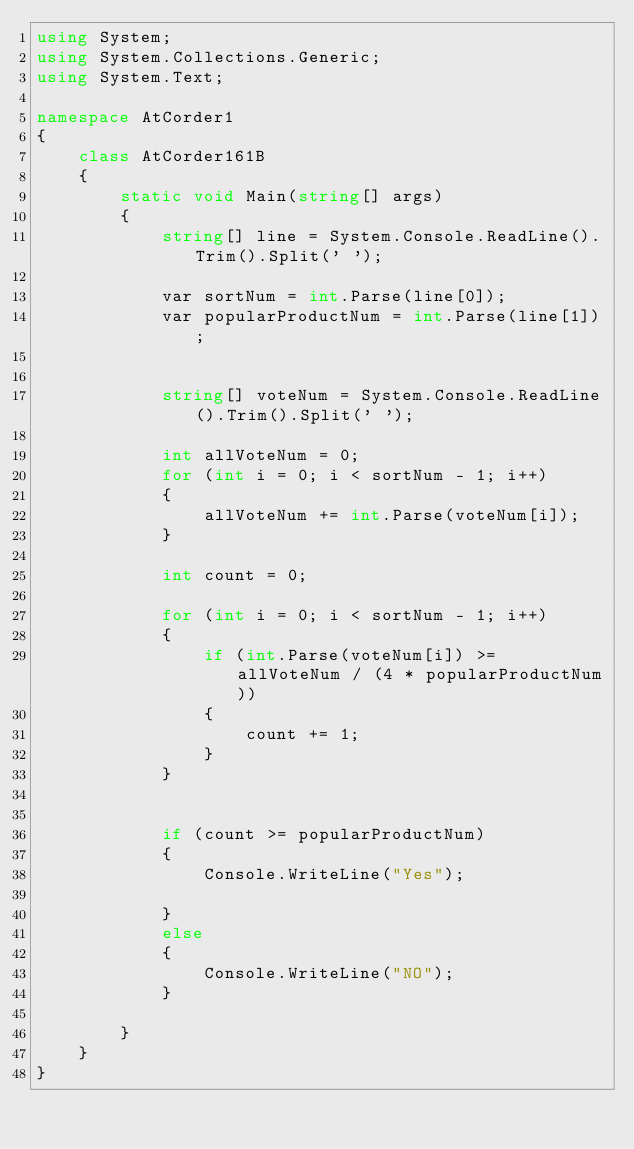Convert code to text. <code><loc_0><loc_0><loc_500><loc_500><_C#_>using System;
using System.Collections.Generic;
using System.Text;

namespace AtCorder1
{
    class AtCorder161B
    {
        static void Main(string[] args)
        {
            string[] line = System.Console.ReadLine().Trim().Split(' ');

            var sortNum = int.Parse(line[0]);
            var popularProductNum = int.Parse(line[1]);


            string[] voteNum = System.Console.ReadLine().Trim().Split(' ');

            int allVoteNum = 0;
            for (int i = 0; i < sortNum - 1; i++)
            {
                allVoteNum += int.Parse(voteNum[i]);
            }

            int count = 0;

            for (int i = 0; i < sortNum - 1; i++)
            {
                if (int.Parse(voteNum[i]) >= allVoteNum / (4 * popularProductNum))
                {
                    count += 1;
                }
            }


            if (count >= popularProductNum)
            {
                Console.WriteLine("Yes");

            }
            else
            {
                Console.WriteLine("NO");
            }

        }
    }
}
</code> 